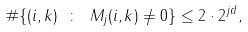<formula> <loc_0><loc_0><loc_500><loc_500>\# \{ ( i , k ) \ \colon \ M _ { j } ( i , k ) \not = 0 \} \leq 2 \cdot 2 ^ { j d } ,</formula> 